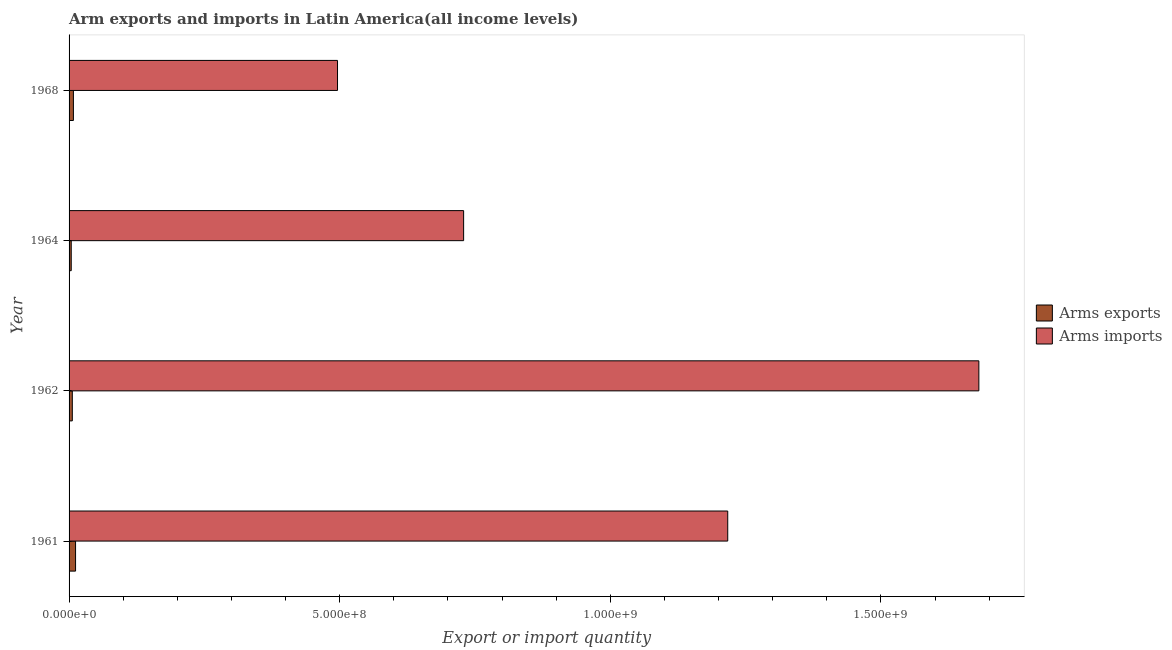How many different coloured bars are there?
Your answer should be very brief. 2. How many groups of bars are there?
Provide a succinct answer. 4. Are the number of bars per tick equal to the number of legend labels?
Ensure brevity in your answer.  Yes. Are the number of bars on each tick of the Y-axis equal?
Your answer should be compact. Yes. How many bars are there on the 3rd tick from the bottom?
Offer a very short reply. 2. What is the label of the 1st group of bars from the top?
Your answer should be very brief. 1968. In how many cases, is the number of bars for a given year not equal to the number of legend labels?
Your answer should be compact. 0. What is the arms exports in 1961?
Ensure brevity in your answer.  1.20e+07. Across all years, what is the maximum arms exports?
Your answer should be very brief. 1.20e+07. Across all years, what is the minimum arms imports?
Offer a terse response. 4.96e+08. In which year was the arms imports maximum?
Offer a terse response. 1962. In which year was the arms exports minimum?
Your answer should be compact. 1964. What is the total arms imports in the graph?
Provide a succinct answer. 4.12e+09. What is the difference between the arms exports in 1961 and that in 1964?
Give a very brief answer. 8.00e+06. What is the difference between the arms imports in 1968 and the arms exports in 1961?
Your response must be concise. 4.84e+08. What is the average arms exports per year?
Give a very brief answer. 7.50e+06. In the year 1961, what is the difference between the arms imports and arms exports?
Your response must be concise. 1.20e+09. What is the ratio of the arms exports in 1962 to that in 1964?
Offer a terse response. 1.5. Is the difference between the arms exports in 1961 and 1962 greater than the difference between the arms imports in 1961 and 1962?
Keep it short and to the point. Yes. What is the difference between the highest and the lowest arms exports?
Ensure brevity in your answer.  8.00e+06. In how many years, is the arms imports greater than the average arms imports taken over all years?
Your response must be concise. 2. What does the 1st bar from the top in 1968 represents?
Make the answer very short. Arms imports. What does the 2nd bar from the bottom in 1968 represents?
Provide a short and direct response. Arms imports. How many bars are there?
Your response must be concise. 8. Are all the bars in the graph horizontal?
Make the answer very short. Yes. How many years are there in the graph?
Keep it short and to the point. 4. Does the graph contain any zero values?
Your answer should be compact. No. Where does the legend appear in the graph?
Ensure brevity in your answer.  Center right. What is the title of the graph?
Make the answer very short. Arm exports and imports in Latin America(all income levels). What is the label or title of the X-axis?
Your answer should be compact. Export or import quantity. What is the Export or import quantity of Arms exports in 1961?
Make the answer very short. 1.20e+07. What is the Export or import quantity in Arms imports in 1961?
Your answer should be compact. 1.22e+09. What is the Export or import quantity of Arms exports in 1962?
Your answer should be very brief. 6.00e+06. What is the Export or import quantity of Arms imports in 1962?
Your answer should be compact. 1.68e+09. What is the Export or import quantity in Arms exports in 1964?
Ensure brevity in your answer.  4.00e+06. What is the Export or import quantity in Arms imports in 1964?
Ensure brevity in your answer.  7.29e+08. What is the Export or import quantity of Arms imports in 1968?
Give a very brief answer. 4.96e+08. Across all years, what is the maximum Export or import quantity of Arms exports?
Offer a terse response. 1.20e+07. Across all years, what is the maximum Export or import quantity in Arms imports?
Make the answer very short. 1.68e+09. Across all years, what is the minimum Export or import quantity in Arms imports?
Your answer should be compact. 4.96e+08. What is the total Export or import quantity of Arms exports in the graph?
Your answer should be compact. 3.00e+07. What is the total Export or import quantity of Arms imports in the graph?
Your response must be concise. 4.12e+09. What is the difference between the Export or import quantity in Arms exports in 1961 and that in 1962?
Provide a succinct answer. 6.00e+06. What is the difference between the Export or import quantity of Arms imports in 1961 and that in 1962?
Give a very brief answer. -4.64e+08. What is the difference between the Export or import quantity in Arms exports in 1961 and that in 1964?
Offer a very short reply. 8.00e+06. What is the difference between the Export or import quantity in Arms imports in 1961 and that in 1964?
Your answer should be very brief. 4.88e+08. What is the difference between the Export or import quantity in Arms exports in 1961 and that in 1968?
Give a very brief answer. 4.00e+06. What is the difference between the Export or import quantity in Arms imports in 1961 and that in 1968?
Keep it short and to the point. 7.21e+08. What is the difference between the Export or import quantity in Arms imports in 1962 and that in 1964?
Ensure brevity in your answer.  9.52e+08. What is the difference between the Export or import quantity of Arms imports in 1962 and that in 1968?
Keep it short and to the point. 1.18e+09. What is the difference between the Export or import quantity of Arms imports in 1964 and that in 1968?
Give a very brief answer. 2.33e+08. What is the difference between the Export or import quantity in Arms exports in 1961 and the Export or import quantity in Arms imports in 1962?
Provide a short and direct response. -1.67e+09. What is the difference between the Export or import quantity in Arms exports in 1961 and the Export or import quantity in Arms imports in 1964?
Keep it short and to the point. -7.17e+08. What is the difference between the Export or import quantity in Arms exports in 1961 and the Export or import quantity in Arms imports in 1968?
Keep it short and to the point. -4.84e+08. What is the difference between the Export or import quantity in Arms exports in 1962 and the Export or import quantity in Arms imports in 1964?
Keep it short and to the point. -7.23e+08. What is the difference between the Export or import quantity of Arms exports in 1962 and the Export or import quantity of Arms imports in 1968?
Your answer should be compact. -4.90e+08. What is the difference between the Export or import quantity of Arms exports in 1964 and the Export or import quantity of Arms imports in 1968?
Give a very brief answer. -4.92e+08. What is the average Export or import quantity of Arms exports per year?
Make the answer very short. 7.50e+06. What is the average Export or import quantity in Arms imports per year?
Your answer should be compact. 1.03e+09. In the year 1961, what is the difference between the Export or import quantity of Arms exports and Export or import quantity of Arms imports?
Your answer should be very brief. -1.20e+09. In the year 1962, what is the difference between the Export or import quantity in Arms exports and Export or import quantity in Arms imports?
Provide a succinct answer. -1.68e+09. In the year 1964, what is the difference between the Export or import quantity of Arms exports and Export or import quantity of Arms imports?
Offer a very short reply. -7.25e+08. In the year 1968, what is the difference between the Export or import quantity of Arms exports and Export or import quantity of Arms imports?
Ensure brevity in your answer.  -4.88e+08. What is the ratio of the Export or import quantity of Arms imports in 1961 to that in 1962?
Make the answer very short. 0.72. What is the ratio of the Export or import quantity in Arms exports in 1961 to that in 1964?
Your answer should be very brief. 3. What is the ratio of the Export or import quantity of Arms imports in 1961 to that in 1964?
Your answer should be compact. 1.67. What is the ratio of the Export or import quantity of Arms imports in 1961 to that in 1968?
Your response must be concise. 2.45. What is the ratio of the Export or import quantity of Arms exports in 1962 to that in 1964?
Your answer should be compact. 1.5. What is the ratio of the Export or import quantity in Arms imports in 1962 to that in 1964?
Provide a succinct answer. 2.31. What is the ratio of the Export or import quantity in Arms imports in 1962 to that in 1968?
Provide a short and direct response. 3.39. What is the ratio of the Export or import quantity of Arms imports in 1964 to that in 1968?
Your response must be concise. 1.47. What is the difference between the highest and the second highest Export or import quantity in Arms exports?
Give a very brief answer. 4.00e+06. What is the difference between the highest and the second highest Export or import quantity in Arms imports?
Ensure brevity in your answer.  4.64e+08. What is the difference between the highest and the lowest Export or import quantity of Arms exports?
Offer a terse response. 8.00e+06. What is the difference between the highest and the lowest Export or import quantity of Arms imports?
Make the answer very short. 1.18e+09. 